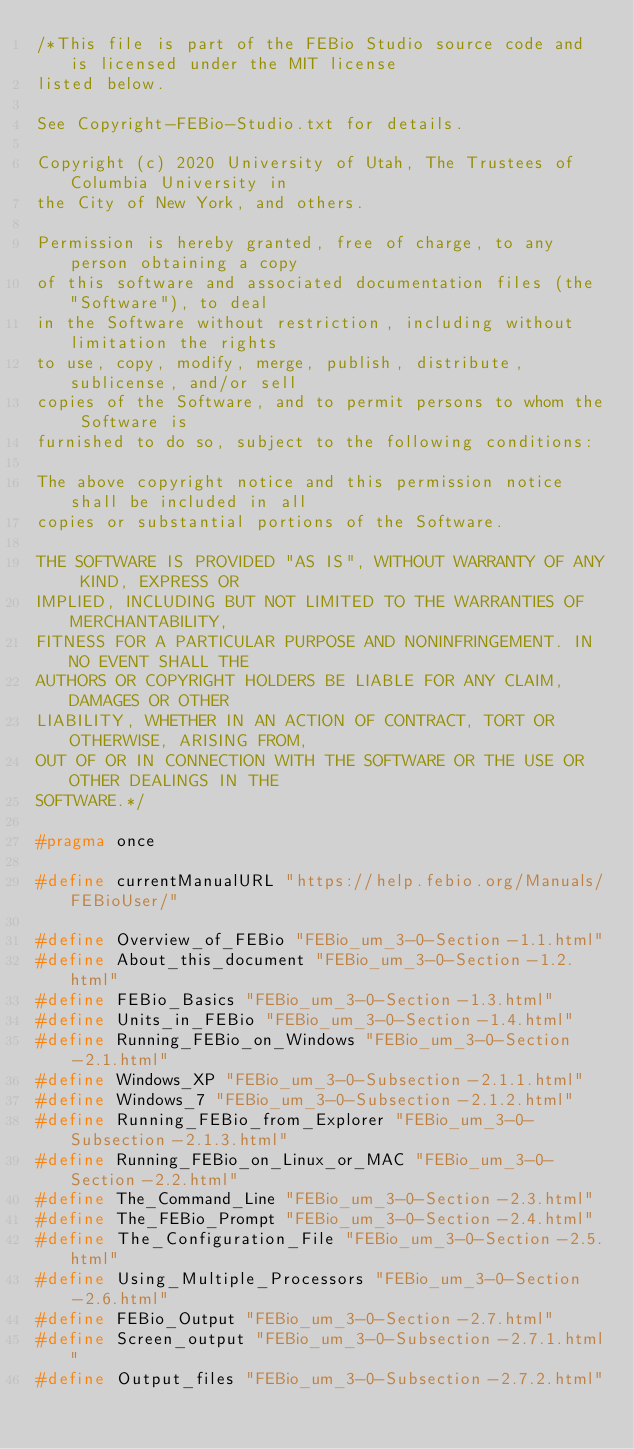Convert code to text. <code><loc_0><loc_0><loc_500><loc_500><_C_>/*This file is part of the FEBio Studio source code and is licensed under the MIT license
listed below.

See Copyright-FEBio-Studio.txt for details.

Copyright (c) 2020 University of Utah, The Trustees of Columbia University in
the City of New York, and others.

Permission is hereby granted, free of charge, to any person obtaining a copy
of this software and associated documentation files (the "Software"), to deal
in the Software without restriction, including without limitation the rights
to use, copy, modify, merge, publish, distribute, sublicense, and/or sell
copies of the Software, and to permit persons to whom the Software is
furnished to do so, subject to the following conditions:

The above copyright notice and this permission notice shall be included in all
copies or substantial portions of the Software.

THE SOFTWARE IS PROVIDED "AS IS", WITHOUT WARRANTY OF ANY KIND, EXPRESS OR
IMPLIED, INCLUDING BUT NOT LIMITED TO THE WARRANTIES OF MERCHANTABILITY,
FITNESS FOR A PARTICULAR PURPOSE AND NONINFRINGEMENT. IN NO EVENT SHALL THE
AUTHORS OR COPYRIGHT HOLDERS BE LIABLE FOR ANY CLAIM, DAMAGES OR OTHER
LIABILITY, WHETHER IN AN ACTION OF CONTRACT, TORT OR OTHERWISE, ARISING FROM,
OUT OF OR IN CONNECTION WITH THE SOFTWARE OR THE USE OR OTHER DEALINGS IN THE
SOFTWARE.*/

#pragma once

#define currentManualURL "https://help.febio.org/Manuals/FEBioUser/"

#define Overview_of_FEBio "FEBio_um_3-0-Section-1.1.html"
#define About_this_document "FEBio_um_3-0-Section-1.2.html"
#define FEBio_Basics "FEBio_um_3-0-Section-1.3.html"
#define Units_in_FEBio "FEBio_um_3-0-Section-1.4.html"
#define Running_FEBio_on_Windows "FEBio_um_3-0-Section-2.1.html"
#define Windows_XP "FEBio_um_3-0-Subsection-2.1.1.html"
#define Windows_7 "FEBio_um_3-0-Subsection-2.1.2.html"
#define Running_FEBio_from_Explorer "FEBio_um_3-0-Subsection-2.1.3.html"
#define Running_FEBio_on_Linux_or_MAC "FEBio_um_3-0-Section-2.2.html"
#define The_Command_Line "FEBio_um_3-0-Section-2.3.html"
#define The_FEBio_Prompt "FEBio_um_3-0-Section-2.4.html"
#define The_Configuration_File "FEBio_um_3-0-Section-2.5.html"
#define Using_Multiple_Processors "FEBio_um_3-0-Section-2.6.html"
#define FEBio_Output "FEBio_um_3-0-Section-2.7.html"
#define Screen_output "FEBio_um_3-0-Subsection-2.7.1.html"
#define Output_files "FEBio_um_3-0-Subsection-2.7.2.html"</code> 